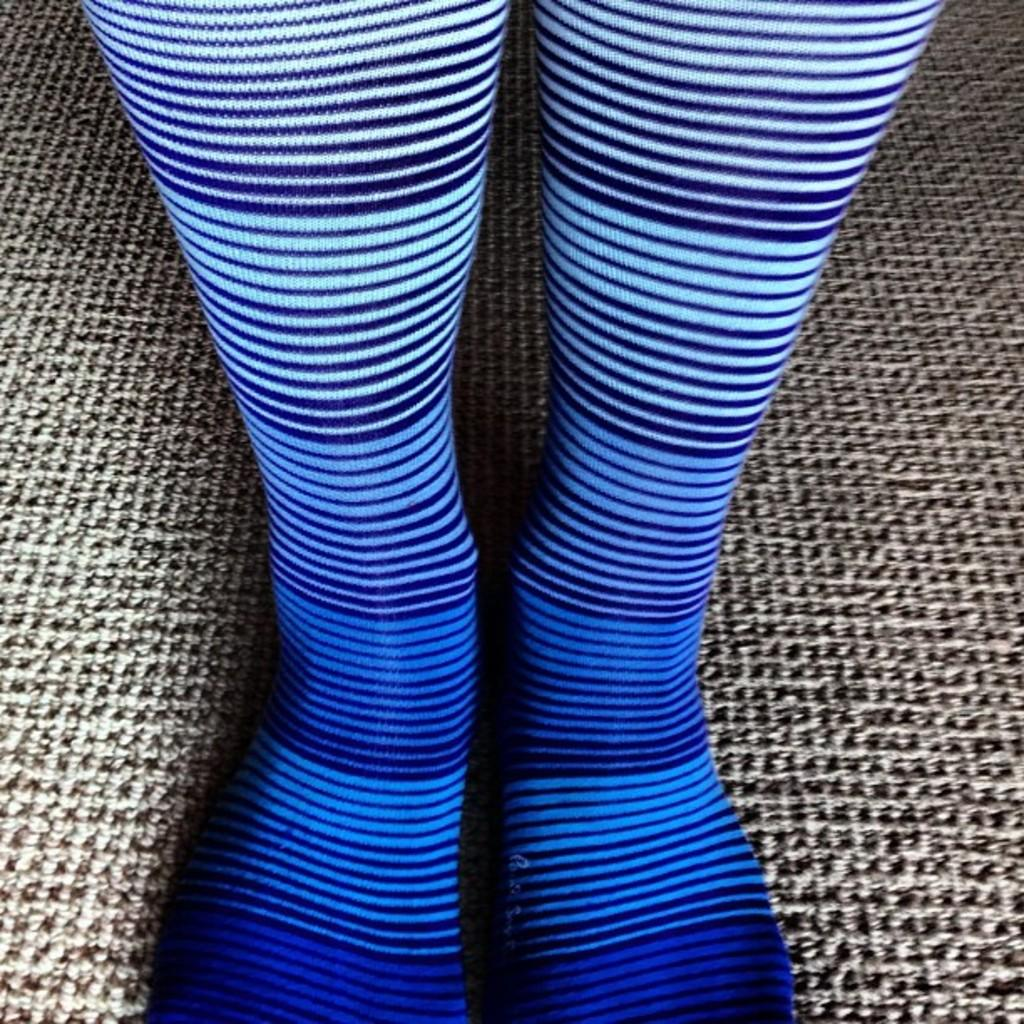What is on the floor in the image? There are legs visible on the floor in the image. Can you describe the position of the legs? The legs are on the floor. Where might this image have been taken? The image may have been taken in a room. What type of arch can be seen in the image? There is no arch present in the image; it features legs on the floor. What emotion is the person feeling based on the image? The image does not provide any information about the person's emotions or feelings. 